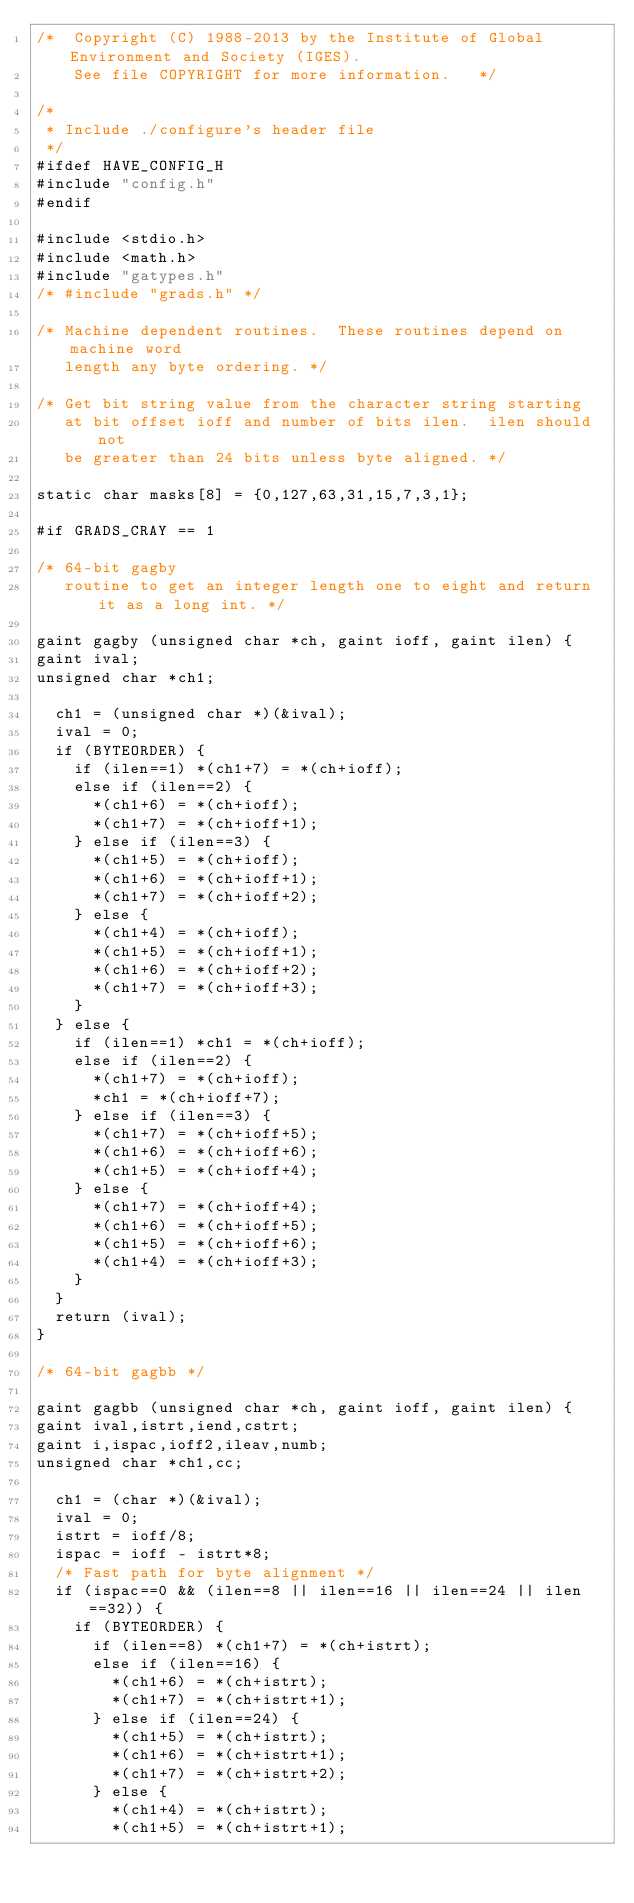<code> <loc_0><loc_0><loc_500><loc_500><_C_>/*  Copyright (C) 1988-2013 by the Institute of Global Environment and Society (IGES).  
    See file COPYRIGHT for more information.   */

/* 
 * Include ./configure's header file
 */
#ifdef HAVE_CONFIG_H
#include "config.h"
#endif

#include <stdio.h>
#include <math.h>
#include "gatypes.h"
/* #include "grads.h" */

/* Machine dependent routines.  These routines depend on machine word
   length any byte ordering. */

/* Get bit string value from the character string starting
   at bit offset ioff and number of bits ilen.  ilen should not
   be greater than 24 bits unless byte aligned. */

static char masks[8] = {0,127,63,31,15,7,3,1};

#if GRADS_CRAY == 1

/* 64-bit gagby 
   routine to get an integer length one to eight and return it as a long int. */

gaint gagby (unsigned char *ch, gaint ioff, gaint ilen) {
gaint ival;
unsigned char *ch1;

  ch1 = (unsigned char *)(&ival);
  ival = 0;
  if (BYTEORDER) {
    if (ilen==1) *(ch1+7) = *(ch+ioff);
    else if (ilen==2) {
      *(ch1+6) = *(ch+ioff);
      *(ch1+7) = *(ch+ioff+1);
    } else if (ilen==3) {
      *(ch1+5) = *(ch+ioff);
      *(ch1+6) = *(ch+ioff+1);
      *(ch1+7) = *(ch+ioff+2);
    } else {
      *(ch1+4) = *(ch+ioff);
      *(ch1+5) = *(ch+ioff+1);
      *(ch1+6) = *(ch+ioff+2);
      *(ch1+7) = *(ch+ioff+3);
    }
  } else {
    if (ilen==1) *ch1 = *(ch+ioff);
    else if (ilen==2) {
      *(ch1+7) = *(ch+ioff);
      *ch1 = *(ch+ioff+7);
    } else if (ilen==3) {
      *(ch1+7) = *(ch+ioff+5);
      *(ch1+6) = *(ch+ioff+6);
      *(ch1+5) = *(ch+ioff+4);
    } else {
      *(ch1+7) = *(ch+ioff+4);
      *(ch1+6) = *(ch+ioff+5);
      *(ch1+5) = *(ch+ioff+6);
      *(ch1+4) = *(ch+ioff+3);
    }
  }
  return (ival);
}

/* 64-bit gagbb */

gaint gagbb (unsigned char *ch, gaint ioff, gaint ilen) {
gaint ival,istrt,iend,cstrt;
gaint i,ispac,ioff2,ileav,numb;
unsigned char *ch1,cc;

  ch1 = (char *)(&ival);
  ival = 0;
  istrt = ioff/8;
  ispac = ioff - istrt*8;
  /* Fast path for byte alignment */
  if (ispac==0 && (ilen==8 || ilen==16 || ilen==24 || ilen==32)) {
    if (BYTEORDER) {
      if (ilen==8) *(ch1+7) = *(ch+istrt);
      else if (ilen==16) {
        *(ch1+6) = *(ch+istrt);
        *(ch1+7) = *(ch+istrt+1);
      } else if (ilen==24) {
        *(ch1+5) = *(ch+istrt);
        *(ch1+6) = *(ch+istrt+1);
        *(ch1+7) = *(ch+istrt+2);
      } else {
        *(ch1+4) = *(ch+istrt);
        *(ch1+5) = *(ch+istrt+1);</code> 